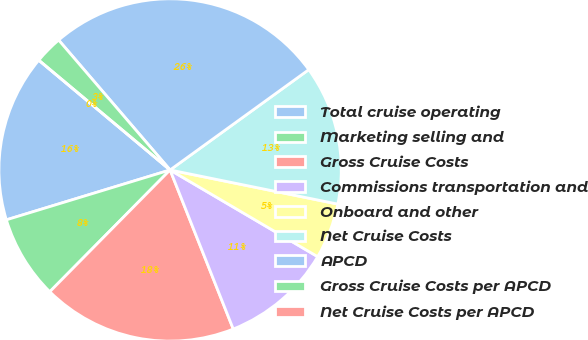Convert chart. <chart><loc_0><loc_0><loc_500><loc_500><pie_chart><fcel>Total cruise operating<fcel>Marketing selling and<fcel>Gross Cruise Costs<fcel>Commissions transportation and<fcel>Onboard and other<fcel>Net Cruise Costs<fcel>APCD<fcel>Gross Cruise Costs per APCD<fcel>Net Cruise Costs per APCD<nl><fcel>15.79%<fcel>7.89%<fcel>18.42%<fcel>10.53%<fcel>5.26%<fcel>13.16%<fcel>26.32%<fcel>2.63%<fcel>0.0%<nl></chart> 